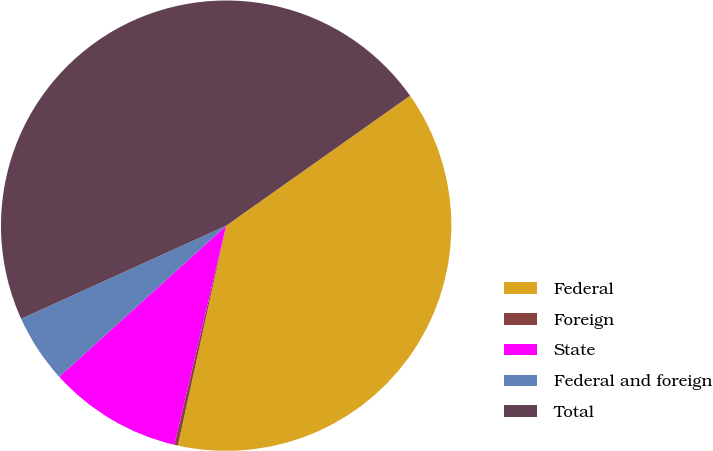<chart> <loc_0><loc_0><loc_500><loc_500><pie_chart><fcel>Federal<fcel>Foreign<fcel>State<fcel>Federal and foreign<fcel>Total<nl><fcel>38.24%<fcel>0.25%<fcel>9.6%<fcel>4.92%<fcel>47.0%<nl></chart> 